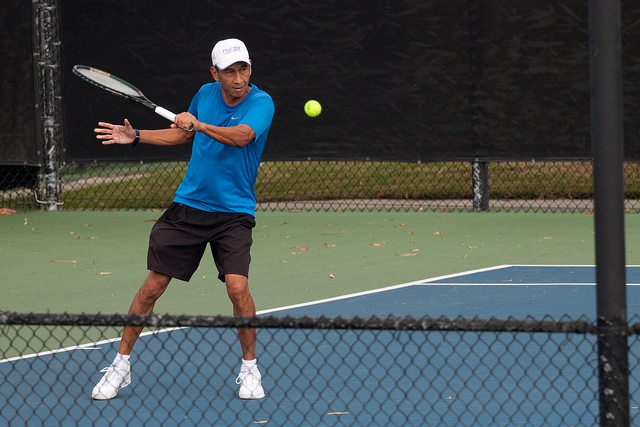Describe the objects in this image and their specific colors. I can see people in black, blue, white, and brown tones, tennis racket in black, darkgray, gray, and lightgray tones, and sports ball in black, yellow, and khaki tones in this image. 